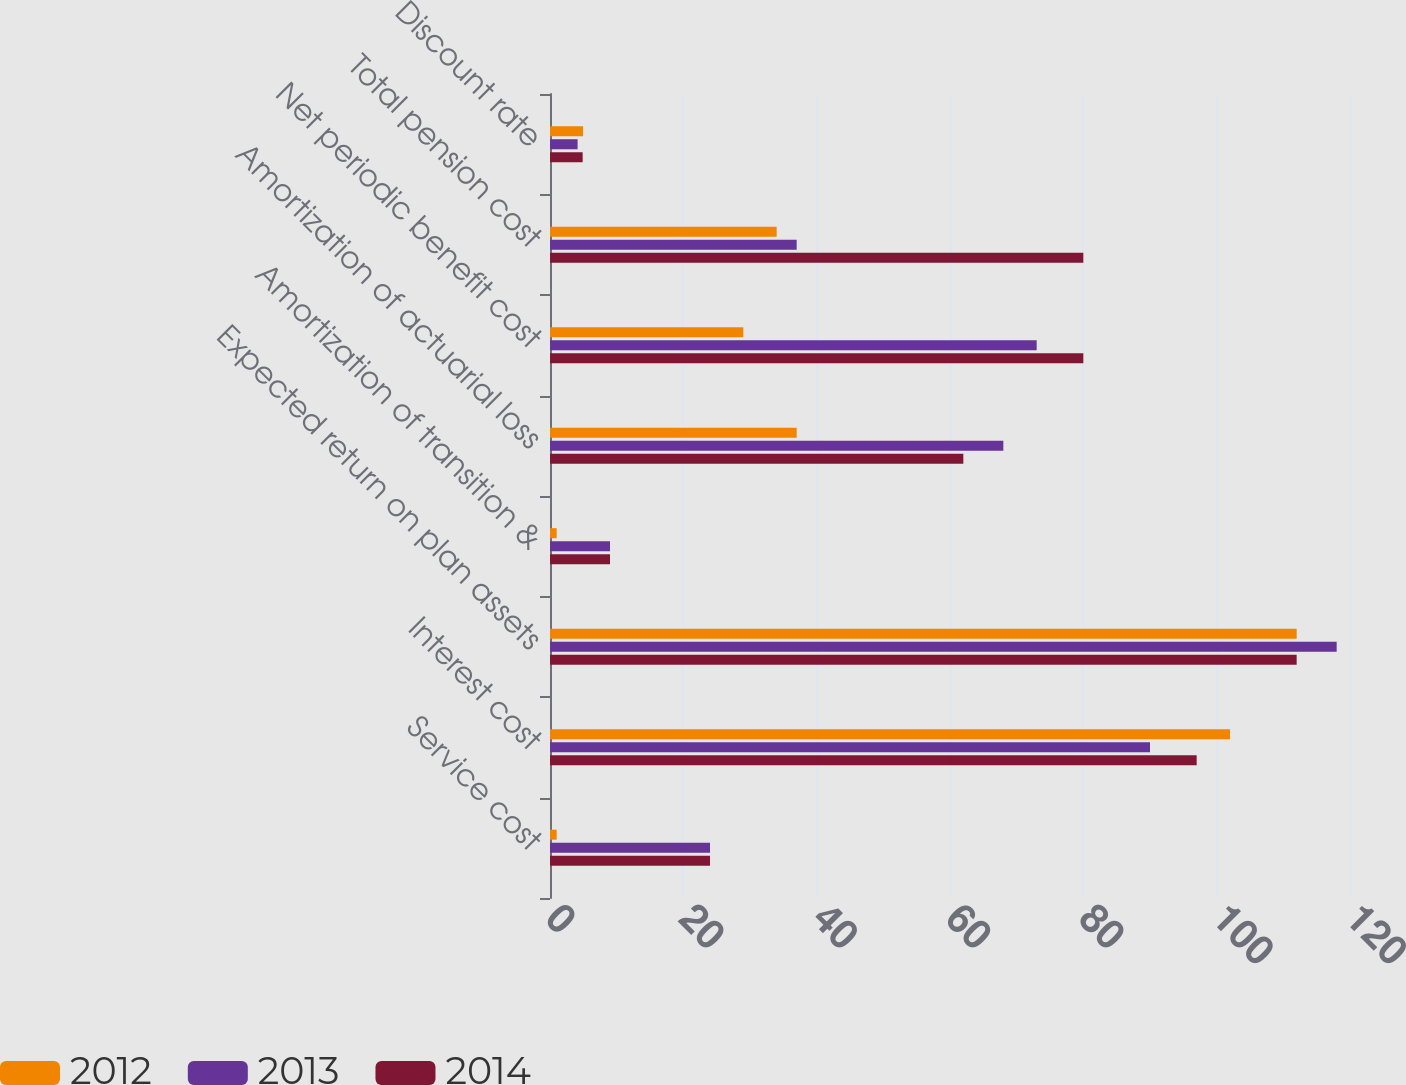Convert chart to OTSL. <chart><loc_0><loc_0><loc_500><loc_500><stacked_bar_chart><ecel><fcel>Service cost<fcel>Interest cost<fcel>Expected return on plan assets<fcel>Amortization of transition &<fcel>Amortization of actuarial loss<fcel>Net periodic benefit cost<fcel>Total pension cost<fcel>Discount rate<nl><fcel>2012<fcel>1<fcel>102<fcel>112<fcel>1<fcel>37<fcel>29<fcel>34<fcel>4.96<nl><fcel>2013<fcel>24<fcel>90<fcel>118<fcel>9<fcel>68<fcel>73<fcel>37<fcel>4.14<nl><fcel>2014<fcel>24<fcel>97<fcel>112<fcel>9<fcel>62<fcel>80<fcel>80<fcel>4.9<nl></chart> 